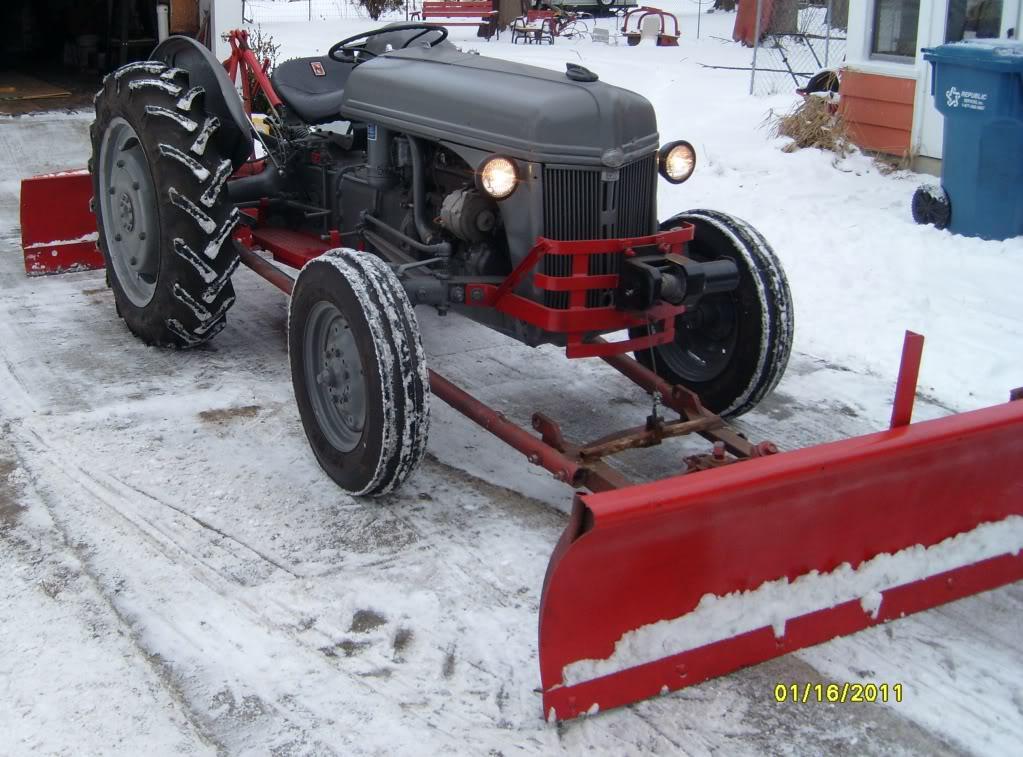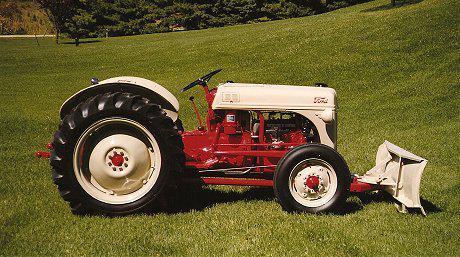The first image is the image on the left, the second image is the image on the right. Examine the images to the left and right. Is the description "Right image shows a tractor with plow on a snow-covered ground." accurate? Answer yes or no. No. The first image is the image on the left, the second image is the image on the right. Examine the images to the left and right. Is the description "there are two trees in the image on the right." accurate? Answer yes or no. No. 